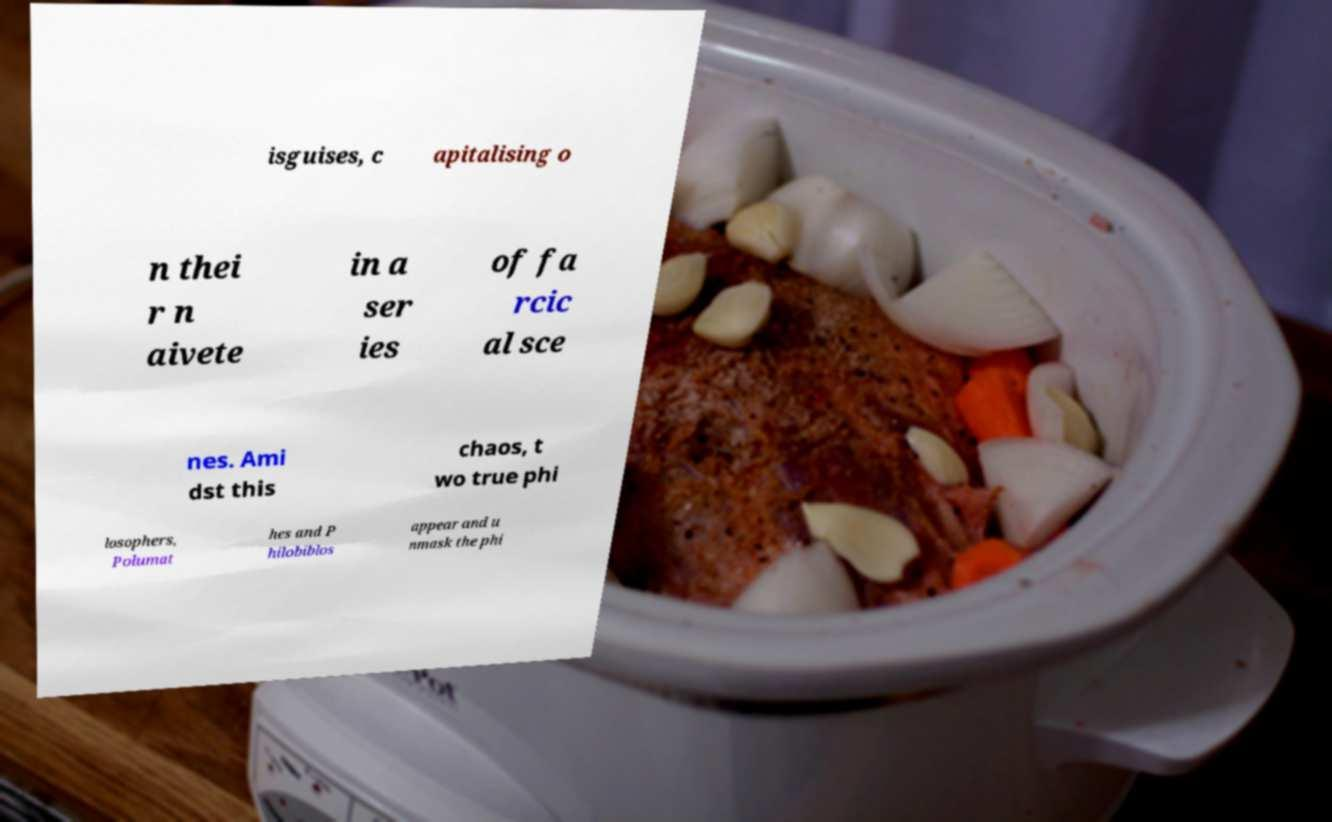There's text embedded in this image that I need extracted. Can you transcribe it verbatim? isguises, c apitalising o n thei r n aivete in a ser ies of fa rcic al sce nes. Ami dst this chaos, t wo true phi losophers, Polumat hes and P hilobiblos appear and u nmask the phi 